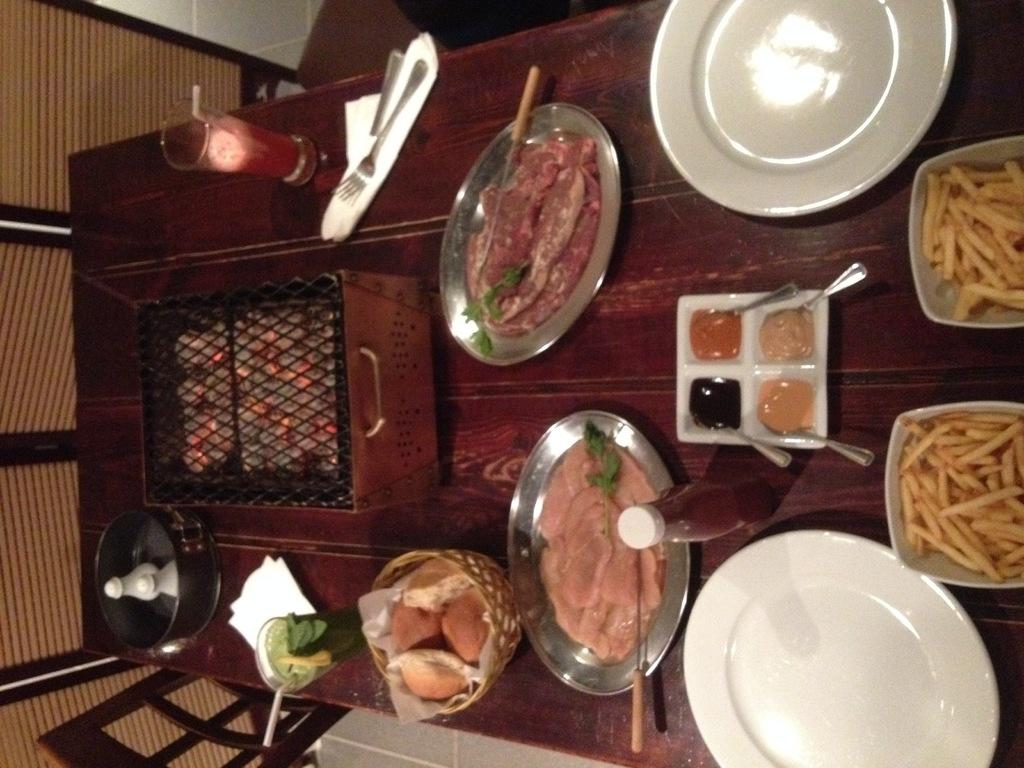What can be found on the table in the image? There are food items, a heater, two glasses, forks, four spoons, a sauce bottle, and plates on the table. What type of utensils are present on the table? There are forks and spoons on the table. How many glasses are on the table? There are two glasses on the table. What is used for serving sauce in the image? There is a sauce bottle on the table. What is used for eating the food items on the table? The forks and spoons on the table can be used for eating the food items. How many frogs are sitting on the table in the image? There are no frogs present on the table in the image. What year is depicted in the image? The image does not depict a specific year; it is a still life of objects on a table. 